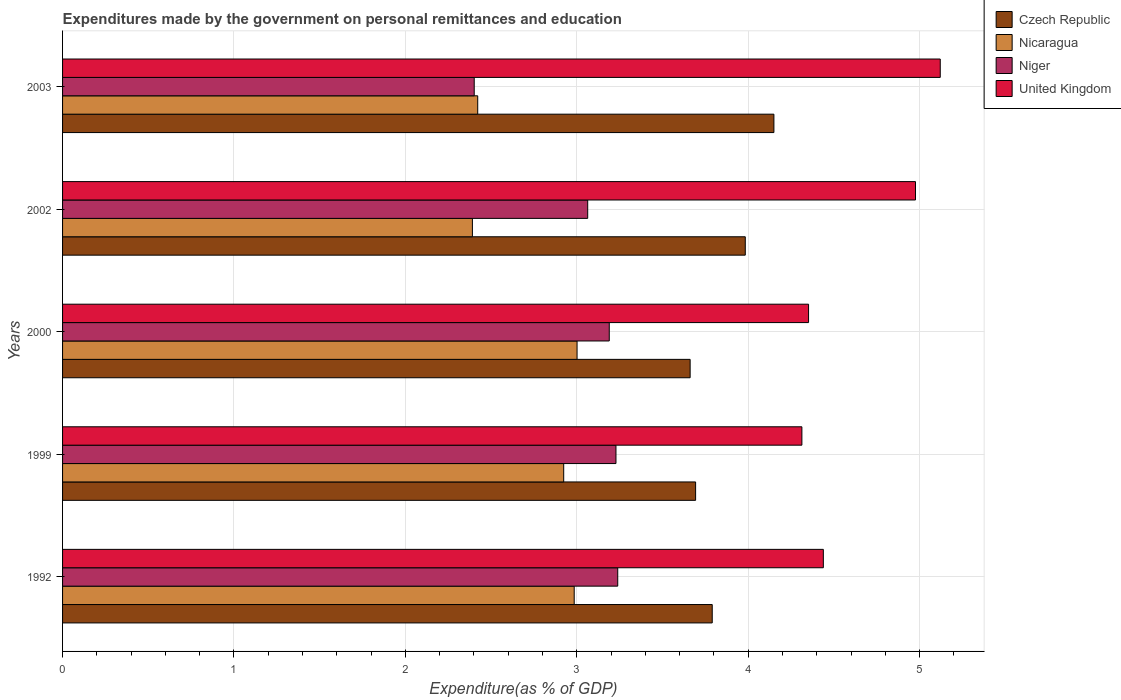How many different coloured bars are there?
Give a very brief answer. 4. Are the number of bars per tick equal to the number of legend labels?
Your answer should be compact. Yes. Are the number of bars on each tick of the Y-axis equal?
Your response must be concise. Yes. How many bars are there on the 4th tick from the top?
Make the answer very short. 4. How many bars are there on the 2nd tick from the bottom?
Ensure brevity in your answer.  4. What is the label of the 3rd group of bars from the top?
Keep it short and to the point. 2000. What is the expenditures made by the government on personal remittances and education in Czech Republic in 2000?
Your response must be concise. 3.66. Across all years, what is the maximum expenditures made by the government on personal remittances and education in Nicaragua?
Your answer should be very brief. 3. Across all years, what is the minimum expenditures made by the government on personal remittances and education in United Kingdom?
Provide a succinct answer. 4.31. In which year was the expenditures made by the government on personal remittances and education in Czech Republic maximum?
Ensure brevity in your answer.  2003. What is the total expenditures made by the government on personal remittances and education in United Kingdom in the graph?
Ensure brevity in your answer.  23.2. What is the difference between the expenditures made by the government on personal remittances and education in Niger in 1992 and that in 2002?
Your answer should be compact. 0.18. What is the difference between the expenditures made by the government on personal remittances and education in Niger in 2000 and the expenditures made by the government on personal remittances and education in Nicaragua in 1999?
Provide a succinct answer. 0.27. What is the average expenditures made by the government on personal remittances and education in Czech Republic per year?
Ensure brevity in your answer.  3.86. In the year 1999, what is the difference between the expenditures made by the government on personal remittances and education in Niger and expenditures made by the government on personal remittances and education in Nicaragua?
Your answer should be compact. 0.3. In how many years, is the expenditures made by the government on personal remittances and education in Niger greater than 4.8 %?
Make the answer very short. 0. What is the ratio of the expenditures made by the government on personal remittances and education in Niger in 1999 to that in 2003?
Ensure brevity in your answer.  1.34. Is the expenditures made by the government on personal remittances and education in Czech Republic in 1992 less than that in 2002?
Provide a succinct answer. Yes. What is the difference between the highest and the second highest expenditures made by the government on personal remittances and education in Nicaragua?
Keep it short and to the point. 0.02. What is the difference between the highest and the lowest expenditures made by the government on personal remittances and education in Czech Republic?
Offer a very short reply. 0.49. In how many years, is the expenditures made by the government on personal remittances and education in United Kingdom greater than the average expenditures made by the government on personal remittances and education in United Kingdom taken over all years?
Provide a succinct answer. 2. Is the sum of the expenditures made by the government on personal remittances and education in United Kingdom in 2002 and 2003 greater than the maximum expenditures made by the government on personal remittances and education in Nicaragua across all years?
Your response must be concise. Yes. Is it the case that in every year, the sum of the expenditures made by the government on personal remittances and education in Niger and expenditures made by the government on personal remittances and education in Nicaragua is greater than the sum of expenditures made by the government on personal remittances and education in United Kingdom and expenditures made by the government on personal remittances and education in Czech Republic?
Offer a terse response. No. What does the 4th bar from the top in 1992 represents?
Your answer should be compact. Czech Republic. What does the 2nd bar from the bottom in 1999 represents?
Your response must be concise. Nicaragua. How many bars are there?
Provide a succinct answer. 20. How many years are there in the graph?
Your response must be concise. 5. What is the difference between two consecutive major ticks on the X-axis?
Offer a terse response. 1. Are the values on the major ticks of X-axis written in scientific E-notation?
Provide a short and direct response. No. Does the graph contain any zero values?
Provide a succinct answer. No. Does the graph contain grids?
Offer a very short reply. Yes. Where does the legend appear in the graph?
Give a very brief answer. Top right. How many legend labels are there?
Keep it short and to the point. 4. How are the legend labels stacked?
Offer a very short reply. Vertical. What is the title of the graph?
Provide a succinct answer. Expenditures made by the government on personal remittances and education. Does "Macedonia" appear as one of the legend labels in the graph?
Ensure brevity in your answer.  No. What is the label or title of the X-axis?
Your answer should be very brief. Expenditure(as % of GDP). What is the label or title of the Y-axis?
Offer a terse response. Years. What is the Expenditure(as % of GDP) of Czech Republic in 1992?
Give a very brief answer. 3.79. What is the Expenditure(as % of GDP) in Nicaragua in 1992?
Keep it short and to the point. 2.98. What is the Expenditure(as % of GDP) in Niger in 1992?
Offer a very short reply. 3.24. What is the Expenditure(as % of GDP) of United Kingdom in 1992?
Offer a terse response. 4.44. What is the Expenditure(as % of GDP) in Czech Republic in 1999?
Ensure brevity in your answer.  3.69. What is the Expenditure(as % of GDP) of Nicaragua in 1999?
Provide a succinct answer. 2.92. What is the Expenditure(as % of GDP) of Niger in 1999?
Your response must be concise. 3.23. What is the Expenditure(as % of GDP) of United Kingdom in 1999?
Your answer should be compact. 4.31. What is the Expenditure(as % of GDP) of Czech Republic in 2000?
Offer a very short reply. 3.66. What is the Expenditure(as % of GDP) of Nicaragua in 2000?
Ensure brevity in your answer.  3. What is the Expenditure(as % of GDP) in Niger in 2000?
Offer a terse response. 3.19. What is the Expenditure(as % of GDP) of United Kingdom in 2000?
Your response must be concise. 4.35. What is the Expenditure(as % of GDP) in Czech Republic in 2002?
Your response must be concise. 3.98. What is the Expenditure(as % of GDP) of Nicaragua in 2002?
Provide a succinct answer. 2.39. What is the Expenditure(as % of GDP) in Niger in 2002?
Your answer should be compact. 3.06. What is the Expenditure(as % of GDP) of United Kingdom in 2002?
Give a very brief answer. 4.98. What is the Expenditure(as % of GDP) in Czech Republic in 2003?
Offer a very short reply. 4.15. What is the Expenditure(as % of GDP) of Nicaragua in 2003?
Your answer should be very brief. 2.42. What is the Expenditure(as % of GDP) of Niger in 2003?
Offer a terse response. 2.4. What is the Expenditure(as % of GDP) of United Kingdom in 2003?
Give a very brief answer. 5.12. Across all years, what is the maximum Expenditure(as % of GDP) of Czech Republic?
Provide a short and direct response. 4.15. Across all years, what is the maximum Expenditure(as % of GDP) of Nicaragua?
Keep it short and to the point. 3. Across all years, what is the maximum Expenditure(as % of GDP) in Niger?
Provide a succinct answer. 3.24. Across all years, what is the maximum Expenditure(as % of GDP) of United Kingdom?
Offer a very short reply. 5.12. Across all years, what is the minimum Expenditure(as % of GDP) of Czech Republic?
Provide a short and direct response. 3.66. Across all years, what is the minimum Expenditure(as % of GDP) in Nicaragua?
Your answer should be compact. 2.39. Across all years, what is the minimum Expenditure(as % of GDP) of Niger?
Give a very brief answer. 2.4. Across all years, what is the minimum Expenditure(as % of GDP) of United Kingdom?
Provide a short and direct response. 4.31. What is the total Expenditure(as % of GDP) of Czech Republic in the graph?
Make the answer very short. 19.28. What is the total Expenditure(as % of GDP) of Nicaragua in the graph?
Offer a terse response. 13.72. What is the total Expenditure(as % of GDP) of Niger in the graph?
Your answer should be very brief. 15.12. What is the total Expenditure(as % of GDP) in United Kingdom in the graph?
Offer a terse response. 23.2. What is the difference between the Expenditure(as % of GDP) in Czech Republic in 1992 and that in 1999?
Provide a short and direct response. 0.1. What is the difference between the Expenditure(as % of GDP) of Nicaragua in 1992 and that in 1999?
Keep it short and to the point. 0.06. What is the difference between the Expenditure(as % of GDP) of Niger in 1992 and that in 1999?
Offer a very short reply. 0.01. What is the difference between the Expenditure(as % of GDP) in United Kingdom in 1992 and that in 1999?
Keep it short and to the point. 0.13. What is the difference between the Expenditure(as % of GDP) of Czech Republic in 1992 and that in 2000?
Your answer should be very brief. 0.13. What is the difference between the Expenditure(as % of GDP) of Nicaragua in 1992 and that in 2000?
Offer a terse response. -0.02. What is the difference between the Expenditure(as % of GDP) in Niger in 1992 and that in 2000?
Ensure brevity in your answer.  0.05. What is the difference between the Expenditure(as % of GDP) of United Kingdom in 1992 and that in 2000?
Ensure brevity in your answer.  0.09. What is the difference between the Expenditure(as % of GDP) of Czech Republic in 1992 and that in 2002?
Make the answer very short. -0.19. What is the difference between the Expenditure(as % of GDP) of Nicaragua in 1992 and that in 2002?
Offer a very short reply. 0.59. What is the difference between the Expenditure(as % of GDP) in Niger in 1992 and that in 2002?
Provide a succinct answer. 0.18. What is the difference between the Expenditure(as % of GDP) in United Kingdom in 1992 and that in 2002?
Your response must be concise. -0.54. What is the difference between the Expenditure(as % of GDP) of Czech Republic in 1992 and that in 2003?
Provide a short and direct response. -0.36. What is the difference between the Expenditure(as % of GDP) in Nicaragua in 1992 and that in 2003?
Make the answer very short. 0.56. What is the difference between the Expenditure(as % of GDP) in Niger in 1992 and that in 2003?
Give a very brief answer. 0.84. What is the difference between the Expenditure(as % of GDP) of United Kingdom in 1992 and that in 2003?
Give a very brief answer. -0.68. What is the difference between the Expenditure(as % of GDP) in Czech Republic in 1999 and that in 2000?
Make the answer very short. 0.03. What is the difference between the Expenditure(as % of GDP) of Nicaragua in 1999 and that in 2000?
Offer a terse response. -0.08. What is the difference between the Expenditure(as % of GDP) in Niger in 1999 and that in 2000?
Give a very brief answer. 0.04. What is the difference between the Expenditure(as % of GDP) in United Kingdom in 1999 and that in 2000?
Offer a terse response. -0.04. What is the difference between the Expenditure(as % of GDP) in Czech Republic in 1999 and that in 2002?
Make the answer very short. -0.29. What is the difference between the Expenditure(as % of GDP) of Nicaragua in 1999 and that in 2002?
Provide a short and direct response. 0.53. What is the difference between the Expenditure(as % of GDP) in Niger in 1999 and that in 2002?
Your answer should be compact. 0.17. What is the difference between the Expenditure(as % of GDP) in United Kingdom in 1999 and that in 2002?
Your answer should be very brief. -0.66. What is the difference between the Expenditure(as % of GDP) of Czech Republic in 1999 and that in 2003?
Offer a very short reply. -0.46. What is the difference between the Expenditure(as % of GDP) in Nicaragua in 1999 and that in 2003?
Your response must be concise. 0.5. What is the difference between the Expenditure(as % of GDP) of Niger in 1999 and that in 2003?
Ensure brevity in your answer.  0.83. What is the difference between the Expenditure(as % of GDP) of United Kingdom in 1999 and that in 2003?
Make the answer very short. -0.81. What is the difference between the Expenditure(as % of GDP) of Czech Republic in 2000 and that in 2002?
Offer a very short reply. -0.32. What is the difference between the Expenditure(as % of GDP) of Nicaragua in 2000 and that in 2002?
Your response must be concise. 0.61. What is the difference between the Expenditure(as % of GDP) in Niger in 2000 and that in 2002?
Ensure brevity in your answer.  0.13. What is the difference between the Expenditure(as % of GDP) of United Kingdom in 2000 and that in 2002?
Offer a very short reply. -0.62. What is the difference between the Expenditure(as % of GDP) in Czech Republic in 2000 and that in 2003?
Keep it short and to the point. -0.49. What is the difference between the Expenditure(as % of GDP) in Nicaragua in 2000 and that in 2003?
Ensure brevity in your answer.  0.58. What is the difference between the Expenditure(as % of GDP) in Niger in 2000 and that in 2003?
Offer a terse response. 0.79. What is the difference between the Expenditure(as % of GDP) of United Kingdom in 2000 and that in 2003?
Give a very brief answer. -0.77. What is the difference between the Expenditure(as % of GDP) of Czech Republic in 2002 and that in 2003?
Make the answer very short. -0.17. What is the difference between the Expenditure(as % of GDP) in Nicaragua in 2002 and that in 2003?
Offer a terse response. -0.03. What is the difference between the Expenditure(as % of GDP) in Niger in 2002 and that in 2003?
Give a very brief answer. 0.66. What is the difference between the Expenditure(as % of GDP) of United Kingdom in 2002 and that in 2003?
Your answer should be very brief. -0.14. What is the difference between the Expenditure(as % of GDP) of Czech Republic in 1992 and the Expenditure(as % of GDP) of Nicaragua in 1999?
Provide a short and direct response. 0.87. What is the difference between the Expenditure(as % of GDP) in Czech Republic in 1992 and the Expenditure(as % of GDP) in Niger in 1999?
Your answer should be very brief. 0.56. What is the difference between the Expenditure(as % of GDP) in Czech Republic in 1992 and the Expenditure(as % of GDP) in United Kingdom in 1999?
Give a very brief answer. -0.52. What is the difference between the Expenditure(as % of GDP) in Nicaragua in 1992 and the Expenditure(as % of GDP) in Niger in 1999?
Make the answer very short. -0.24. What is the difference between the Expenditure(as % of GDP) of Nicaragua in 1992 and the Expenditure(as % of GDP) of United Kingdom in 1999?
Keep it short and to the point. -1.33. What is the difference between the Expenditure(as % of GDP) in Niger in 1992 and the Expenditure(as % of GDP) in United Kingdom in 1999?
Your answer should be compact. -1.07. What is the difference between the Expenditure(as % of GDP) of Czech Republic in 1992 and the Expenditure(as % of GDP) of Nicaragua in 2000?
Your answer should be compact. 0.79. What is the difference between the Expenditure(as % of GDP) in Czech Republic in 1992 and the Expenditure(as % of GDP) in Niger in 2000?
Give a very brief answer. 0.6. What is the difference between the Expenditure(as % of GDP) of Czech Republic in 1992 and the Expenditure(as % of GDP) of United Kingdom in 2000?
Your answer should be very brief. -0.56. What is the difference between the Expenditure(as % of GDP) of Nicaragua in 1992 and the Expenditure(as % of GDP) of Niger in 2000?
Offer a terse response. -0.2. What is the difference between the Expenditure(as % of GDP) of Nicaragua in 1992 and the Expenditure(as % of GDP) of United Kingdom in 2000?
Your response must be concise. -1.37. What is the difference between the Expenditure(as % of GDP) of Niger in 1992 and the Expenditure(as % of GDP) of United Kingdom in 2000?
Offer a terse response. -1.11. What is the difference between the Expenditure(as % of GDP) in Czech Republic in 1992 and the Expenditure(as % of GDP) in Nicaragua in 2002?
Provide a short and direct response. 1.4. What is the difference between the Expenditure(as % of GDP) in Czech Republic in 1992 and the Expenditure(as % of GDP) in Niger in 2002?
Provide a succinct answer. 0.73. What is the difference between the Expenditure(as % of GDP) in Czech Republic in 1992 and the Expenditure(as % of GDP) in United Kingdom in 2002?
Offer a terse response. -1.19. What is the difference between the Expenditure(as % of GDP) of Nicaragua in 1992 and the Expenditure(as % of GDP) of Niger in 2002?
Your answer should be compact. -0.08. What is the difference between the Expenditure(as % of GDP) of Nicaragua in 1992 and the Expenditure(as % of GDP) of United Kingdom in 2002?
Keep it short and to the point. -1.99. What is the difference between the Expenditure(as % of GDP) of Niger in 1992 and the Expenditure(as % of GDP) of United Kingdom in 2002?
Provide a short and direct response. -1.74. What is the difference between the Expenditure(as % of GDP) in Czech Republic in 1992 and the Expenditure(as % of GDP) in Nicaragua in 2003?
Your answer should be very brief. 1.37. What is the difference between the Expenditure(as % of GDP) in Czech Republic in 1992 and the Expenditure(as % of GDP) in Niger in 2003?
Offer a terse response. 1.39. What is the difference between the Expenditure(as % of GDP) in Czech Republic in 1992 and the Expenditure(as % of GDP) in United Kingdom in 2003?
Offer a very short reply. -1.33. What is the difference between the Expenditure(as % of GDP) of Nicaragua in 1992 and the Expenditure(as % of GDP) of Niger in 2003?
Your answer should be compact. 0.58. What is the difference between the Expenditure(as % of GDP) of Nicaragua in 1992 and the Expenditure(as % of GDP) of United Kingdom in 2003?
Provide a short and direct response. -2.14. What is the difference between the Expenditure(as % of GDP) of Niger in 1992 and the Expenditure(as % of GDP) of United Kingdom in 2003?
Your answer should be compact. -1.88. What is the difference between the Expenditure(as % of GDP) in Czech Republic in 1999 and the Expenditure(as % of GDP) in Nicaragua in 2000?
Your response must be concise. 0.69. What is the difference between the Expenditure(as % of GDP) of Czech Republic in 1999 and the Expenditure(as % of GDP) of Niger in 2000?
Provide a short and direct response. 0.5. What is the difference between the Expenditure(as % of GDP) in Czech Republic in 1999 and the Expenditure(as % of GDP) in United Kingdom in 2000?
Provide a short and direct response. -0.66. What is the difference between the Expenditure(as % of GDP) in Nicaragua in 1999 and the Expenditure(as % of GDP) in Niger in 2000?
Make the answer very short. -0.27. What is the difference between the Expenditure(as % of GDP) of Nicaragua in 1999 and the Expenditure(as % of GDP) of United Kingdom in 2000?
Keep it short and to the point. -1.43. What is the difference between the Expenditure(as % of GDP) in Niger in 1999 and the Expenditure(as % of GDP) in United Kingdom in 2000?
Your answer should be very brief. -1.12. What is the difference between the Expenditure(as % of GDP) of Czech Republic in 1999 and the Expenditure(as % of GDP) of Nicaragua in 2002?
Offer a very short reply. 1.3. What is the difference between the Expenditure(as % of GDP) in Czech Republic in 1999 and the Expenditure(as % of GDP) in Niger in 2002?
Provide a short and direct response. 0.63. What is the difference between the Expenditure(as % of GDP) of Czech Republic in 1999 and the Expenditure(as % of GDP) of United Kingdom in 2002?
Ensure brevity in your answer.  -1.28. What is the difference between the Expenditure(as % of GDP) in Nicaragua in 1999 and the Expenditure(as % of GDP) in Niger in 2002?
Ensure brevity in your answer.  -0.14. What is the difference between the Expenditure(as % of GDP) in Nicaragua in 1999 and the Expenditure(as % of GDP) in United Kingdom in 2002?
Ensure brevity in your answer.  -2.05. What is the difference between the Expenditure(as % of GDP) of Niger in 1999 and the Expenditure(as % of GDP) of United Kingdom in 2002?
Offer a very short reply. -1.75. What is the difference between the Expenditure(as % of GDP) in Czech Republic in 1999 and the Expenditure(as % of GDP) in Nicaragua in 2003?
Offer a very short reply. 1.27. What is the difference between the Expenditure(as % of GDP) of Czech Republic in 1999 and the Expenditure(as % of GDP) of Niger in 2003?
Provide a short and direct response. 1.29. What is the difference between the Expenditure(as % of GDP) of Czech Republic in 1999 and the Expenditure(as % of GDP) of United Kingdom in 2003?
Your response must be concise. -1.43. What is the difference between the Expenditure(as % of GDP) of Nicaragua in 1999 and the Expenditure(as % of GDP) of Niger in 2003?
Make the answer very short. 0.52. What is the difference between the Expenditure(as % of GDP) of Nicaragua in 1999 and the Expenditure(as % of GDP) of United Kingdom in 2003?
Your answer should be very brief. -2.2. What is the difference between the Expenditure(as % of GDP) in Niger in 1999 and the Expenditure(as % of GDP) in United Kingdom in 2003?
Ensure brevity in your answer.  -1.89. What is the difference between the Expenditure(as % of GDP) of Czech Republic in 2000 and the Expenditure(as % of GDP) of Nicaragua in 2002?
Ensure brevity in your answer.  1.27. What is the difference between the Expenditure(as % of GDP) of Czech Republic in 2000 and the Expenditure(as % of GDP) of Niger in 2002?
Your response must be concise. 0.6. What is the difference between the Expenditure(as % of GDP) in Czech Republic in 2000 and the Expenditure(as % of GDP) in United Kingdom in 2002?
Offer a very short reply. -1.31. What is the difference between the Expenditure(as % of GDP) in Nicaragua in 2000 and the Expenditure(as % of GDP) in Niger in 2002?
Make the answer very short. -0.06. What is the difference between the Expenditure(as % of GDP) in Nicaragua in 2000 and the Expenditure(as % of GDP) in United Kingdom in 2002?
Ensure brevity in your answer.  -1.97. What is the difference between the Expenditure(as % of GDP) in Niger in 2000 and the Expenditure(as % of GDP) in United Kingdom in 2002?
Your response must be concise. -1.79. What is the difference between the Expenditure(as % of GDP) of Czech Republic in 2000 and the Expenditure(as % of GDP) of Nicaragua in 2003?
Ensure brevity in your answer.  1.24. What is the difference between the Expenditure(as % of GDP) of Czech Republic in 2000 and the Expenditure(as % of GDP) of Niger in 2003?
Provide a succinct answer. 1.26. What is the difference between the Expenditure(as % of GDP) of Czech Republic in 2000 and the Expenditure(as % of GDP) of United Kingdom in 2003?
Your answer should be very brief. -1.46. What is the difference between the Expenditure(as % of GDP) in Nicaragua in 2000 and the Expenditure(as % of GDP) in Niger in 2003?
Your answer should be compact. 0.6. What is the difference between the Expenditure(as % of GDP) of Nicaragua in 2000 and the Expenditure(as % of GDP) of United Kingdom in 2003?
Keep it short and to the point. -2.12. What is the difference between the Expenditure(as % of GDP) of Niger in 2000 and the Expenditure(as % of GDP) of United Kingdom in 2003?
Offer a very short reply. -1.93. What is the difference between the Expenditure(as % of GDP) of Czech Republic in 2002 and the Expenditure(as % of GDP) of Nicaragua in 2003?
Your response must be concise. 1.56. What is the difference between the Expenditure(as % of GDP) in Czech Republic in 2002 and the Expenditure(as % of GDP) in Niger in 2003?
Offer a very short reply. 1.58. What is the difference between the Expenditure(as % of GDP) in Czech Republic in 2002 and the Expenditure(as % of GDP) in United Kingdom in 2003?
Your answer should be very brief. -1.14. What is the difference between the Expenditure(as % of GDP) in Nicaragua in 2002 and the Expenditure(as % of GDP) in Niger in 2003?
Offer a very short reply. -0.01. What is the difference between the Expenditure(as % of GDP) of Nicaragua in 2002 and the Expenditure(as % of GDP) of United Kingdom in 2003?
Your answer should be very brief. -2.73. What is the difference between the Expenditure(as % of GDP) of Niger in 2002 and the Expenditure(as % of GDP) of United Kingdom in 2003?
Provide a succinct answer. -2.06. What is the average Expenditure(as % of GDP) of Czech Republic per year?
Your response must be concise. 3.86. What is the average Expenditure(as % of GDP) in Nicaragua per year?
Provide a short and direct response. 2.74. What is the average Expenditure(as % of GDP) of Niger per year?
Give a very brief answer. 3.02. What is the average Expenditure(as % of GDP) of United Kingdom per year?
Your response must be concise. 4.64. In the year 1992, what is the difference between the Expenditure(as % of GDP) of Czech Republic and Expenditure(as % of GDP) of Nicaragua?
Your response must be concise. 0.81. In the year 1992, what is the difference between the Expenditure(as % of GDP) of Czech Republic and Expenditure(as % of GDP) of Niger?
Make the answer very short. 0.55. In the year 1992, what is the difference between the Expenditure(as % of GDP) of Czech Republic and Expenditure(as % of GDP) of United Kingdom?
Offer a terse response. -0.65. In the year 1992, what is the difference between the Expenditure(as % of GDP) of Nicaragua and Expenditure(as % of GDP) of Niger?
Keep it short and to the point. -0.25. In the year 1992, what is the difference between the Expenditure(as % of GDP) of Nicaragua and Expenditure(as % of GDP) of United Kingdom?
Provide a succinct answer. -1.45. In the year 1992, what is the difference between the Expenditure(as % of GDP) of Niger and Expenditure(as % of GDP) of United Kingdom?
Ensure brevity in your answer.  -1.2. In the year 1999, what is the difference between the Expenditure(as % of GDP) in Czech Republic and Expenditure(as % of GDP) in Nicaragua?
Offer a very short reply. 0.77. In the year 1999, what is the difference between the Expenditure(as % of GDP) in Czech Republic and Expenditure(as % of GDP) in Niger?
Your answer should be very brief. 0.46. In the year 1999, what is the difference between the Expenditure(as % of GDP) of Czech Republic and Expenditure(as % of GDP) of United Kingdom?
Provide a succinct answer. -0.62. In the year 1999, what is the difference between the Expenditure(as % of GDP) of Nicaragua and Expenditure(as % of GDP) of Niger?
Your answer should be compact. -0.3. In the year 1999, what is the difference between the Expenditure(as % of GDP) in Nicaragua and Expenditure(as % of GDP) in United Kingdom?
Offer a terse response. -1.39. In the year 1999, what is the difference between the Expenditure(as % of GDP) of Niger and Expenditure(as % of GDP) of United Kingdom?
Give a very brief answer. -1.08. In the year 2000, what is the difference between the Expenditure(as % of GDP) in Czech Republic and Expenditure(as % of GDP) in Nicaragua?
Your answer should be compact. 0.66. In the year 2000, what is the difference between the Expenditure(as % of GDP) in Czech Republic and Expenditure(as % of GDP) in Niger?
Make the answer very short. 0.47. In the year 2000, what is the difference between the Expenditure(as % of GDP) in Czech Republic and Expenditure(as % of GDP) in United Kingdom?
Provide a short and direct response. -0.69. In the year 2000, what is the difference between the Expenditure(as % of GDP) of Nicaragua and Expenditure(as % of GDP) of Niger?
Ensure brevity in your answer.  -0.19. In the year 2000, what is the difference between the Expenditure(as % of GDP) of Nicaragua and Expenditure(as % of GDP) of United Kingdom?
Your answer should be compact. -1.35. In the year 2000, what is the difference between the Expenditure(as % of GDP) of Niger and Expenditure(as % of GDP) of United Kingdom?
Your answer should be very brief. -1.16. In the year 2002, what is the difference between the Expenditure(as % of GDP) of Czech Republic and Expenditure(as % of GDP) of Nicaragua?
Ensure brevity in your answer.  1.59. In the year 2002, what is the difference between the Expenditure(as % of GDP) in Czech Republic and Expenditure(as % of GDP) in Niger?
Make the answer very short. 0.92. In the year 2002, what is the difference between the Expenditure(as % of GDP) in Czech Republic and Expenditure(as % of GDP) in United Kingdom?
Your answer should be compact. -0.99. In the year 2002, what is the difference between the Expenditure(as % of GDP) of Nicaragua and Expenditure(as % of GDP) of Niger?
Provide a succinct answer. -0.67. In the year 2002, what is the difference between the Expenditure(as % of GDP) in Nicaragua and Expenditure(as % of GDP) in United Kingdom?
Keep it short and to the point. -2.59. In the year 2002, what is the difference between the Expenditure(as % of GDP) in Niger and Expenditure(as % of GDP) in United Kingdom?
Provide a short and direct response. -1.91. In the year 2003, what is the difference between the Expenditure(as % of GDP) in Czech Republic and Expenditure(as % of GDP) in Nicaragua?
Ensure brevity in your answer.  1.73. In the year 2003, what is the difference between the Expenditure(as % of GDP) of Czech Republic and Expenditure(as % of GDP) of Niger?
Ensure brevity in your answer.  1.75. In the year 2003, what is the difference between the Expenditure(as % of GDP) in Czech Republic and Expenditure(as % of GDP) in United Kingdom?
Provide a short and direct response. -0.97. In the year 2003, what is the difference between the Expenditure(as % of GDP) of Nicaragua and Expenditure(as % of GDP) of Niger?
Provide a short and direct response. 0.02. In the year 2003, what is the difference between the Expenditure(as % of GDP) in Nicaragua and Expenditure(as % of GDP) in United Kingdom?
Offer a very short reply. -2.7. In the year 2003, what is the difference between the Expenditure(as % of GDP) of Niger and Expenditure(as % of GDP) of United Kingdom?
Provide a short and direct response. -2.72. What is the ratio of the Expenditure(as % of GDP) in Czech Republic in 1992 to that in 1999?
Offer a very short reply. 1.03. What is the ratio of the Expenditure(as % of GDP) in Nicaragua in 1992 to that in 1999?
Keep it short and to the point. 1.02. What is the ratio of the Expenditure(as % of GDP) of Czech Republic in 1992 to that in 2000?
Your answer should be compact. 1.04. What is the ratio of the Expenditure(as % of GDP) in Nicaragua in 1992 to that in 2000?
Give a very brief answer. 0.99. What is the ratio of the Expenditure(as % of GDP) in Niger in 1992 to that in 2000?
Offer a terse response. 1.02. What is the ratio of the Expenditure(as % of GDP) of United Kingdom in 1992 to that in 2000?
Your answer should be very brief. 1.02. What is the ratio of the Expenditure(as % of GDP) in Czech Republic in 1992 to that in 2002?
Keep it short and to the point. 0.95. What is the ratio of the Expenditure(as % of GDP) of Nicaragua in 1992 to that in 2002?
Provide a succinct answer. 1.25. What is the ratio of the Expenditure(as % of GDP) in Niger in 1992 to that in 2002?
Offer a very short reply. 1.06. What is the ratio of the Expenditure(as % of GDP) in United Kingdom in 1992 to that in 2002?
Your answer should be very brief. 0.89. What is the ratio of the Expenditure(as % of GDP) in Czech Republic in 1992 to that in 2003?
Your answer should be compact. 0.91. What is the ratio of the Expenditure(as % of GDP) in Nicaragua in 1992 to that in 2003?
Your response must be concise. 1.23. What is the ratio of the Expenditure(as % of GDP) of Niger in 1992 to that in 2003?
Provide a short and direct response. 1.35. What is the ratio of the Expenditure(as % of GDP) in United Kingdom in 1992 to that in 2003?
Your answer should be compact. 0.87. What is the ratio of the Expenditure(as % of GDP) of Czech Republic in 1999 to that in 2000?
Offer a terse response. 1.01. What is the ratio of the Expenditure(as % of GDP) of Niger in 1999 to that in 2000?
Your answer should be compact. 1.01. What is the ratio of the Expenditure(as % of GDP) of United Kingdom in 1999 to that in 2000?
Your answer should be very brief. 0.99. What is the ratio of the Expenditure(as % of GDP) of Czech Republic in 1999 to that in 2002?
Your answer should be very brief. 0.93. What is the ratio of the Expenditure(as % of GDP) of Nicaragua in 1999 to that in 2002?
Provide a succinct answer. 1.22. What is the ratio of the Expenditure(as % of GDP) of Niger in 1999 to that in 2002?
Provide a succinct answer. 1.05. What is the ratio of the Expenditure(as % of GDP) in United Kingdom in 1999 to that in 2002?
Make the answer very short. 0.87. What is the ratio of the Expenditure(as % of GDP) of Czech Republic in 1999 to that in 2003?
Your response must be concise. 0.89. What is the ratio of the Expenditure(as % of GDP) of Nicaragua in 1999 to that in 2003?
Make the answer very short. 1.21. What is the ratio of the Expenditure(as % of GDP) in Niger in 1999 to that in 2003?
Provide a short and direct response. 1.34. What is the ratio of the Expenditure(as % of GDP) in United Kingdom in 1999 to that in 2003?
Keep it short and to the point. 0.84. What is the ratio of the Expenditure(as % of GDP) in Czech Republic in 2000 to that in 2002?
Offer a very short reply. 0.92. What is the ratio of the Expenditure(as % of GDP) of Nicaragua in 2000 to that in 2002?
Offer a very short reply. 1.26. What is the ratio of the Expenditure(as % of GDP) of Niger in 2000 to that in 2002?
Offer a very short reply. 1.04. What is the ratio of the Expenditure(as % of GDP) of United Kingdom in 2000 to that in 2002?
Your answer should be very brief. 0.87. What is the ratio of the Expenditure(as % of GDP) of Czech Republic in 2000 to that in 2003?
Your answer should be compact. 0.88. What is the ratio of the Expenditure(as % of GDP) of Nicaragua in 2000 to that in 2003?
Your answer should be compact. 1.24. What is the ratio of the Expenditure(as % of GDP) in Niger in 2000 to that in 2003?
Your response must be concise. 1.33. What is the ratio of the Expenditure(as % of GDP) in Czech Republic in 2002 to that in 2003?
Offer a terse response. 0.96. What is the ratio of the Expenditure(as % of GDP) in Nicaragua in 2002 to that in 2003?
Offer a very short reply. 0.99. What is the ratio of the Expenditure(as % of GDP) in Niger in 2002 to that in 2003?
Provide a succinct answer. 1.28. What is the ratio of the Expenditure(as % of GDP) of United Kingdom in 2002 to that in 2003?
Provide a short and direct response. 0.97. What is the difference between the highest and the second highest Expenditure(as % of GDP) in Czech Republic?
Provide a short and direct response. 0.17. What is the difference between the highest and the second highest Expenditure(as % of GDP) in Nicaragua?
Your response must be concise. 0.02. What is the difference between the highest and the second highest Expenditure(as % of GDP) in Niger?
Keep it short and to the point. 0.01. What is the difference between the highest and the second highest Expenditure(as % of GDP) of United Kingdom?
Offer a terse response. 0.14. What is the difference between the highest and the lowest Expenditure(as % of GDP) of Czech Republic?
Your response must be concise. 0.49. What is the difference between the highest and the lowest Expenditure(as % of GDP) in Nicaragua?
Give a very brief answer. 0.61. What is the difference between the highest and the lowest Expenditure(as % of GDP) in Niger?
Give a very brief answer. 0.84. What is the difference between the highest and the lowest Expenditure(as % of GDP) of United Kingdom?
Provide a short and direct response. 0.81. 